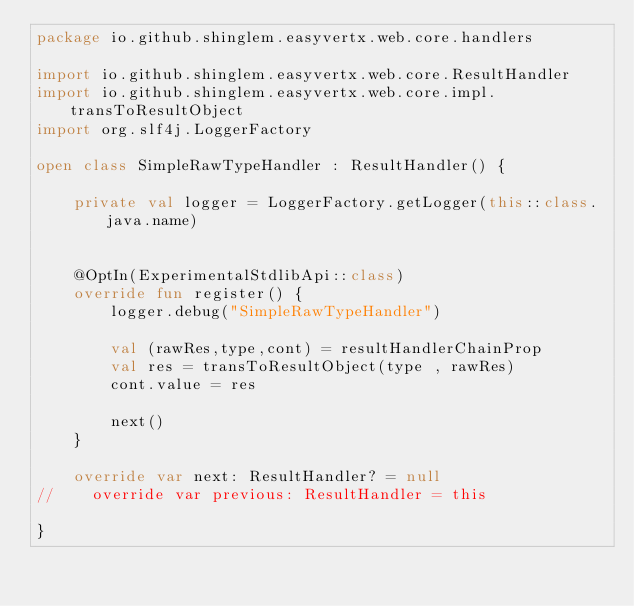<code> <loc_0><loc_0><loc_500><loc_500><_Kotlin_>package io.github.shinglem.easyvertx.web.core.handlers

import io.github.shinglem.easyvertx.web.core.ResultHandler
import io.github.shinglem.easyvertx.web.core.impl.transToResultObject
import org.slf4j.LoggerFactory

open class SimpleRawTypeHandler : ResultHandler() {

    private val logger = LoggerFactory.getLogger(this::class.java.name)


    @OptIn(ExperimentalStdlibApi::class)
    override fun register() {
        logger.debug("SimpleRawTypeHandler")

        val (rawRes,type,cont) = resultHandlerChainProp
        val res = transToResultObject(type , rawRes)
        cont.value = res

        next()
    }

    override var next: ResultHandler? = null
//    override var previous: ResultHandler = this

}


</code> 